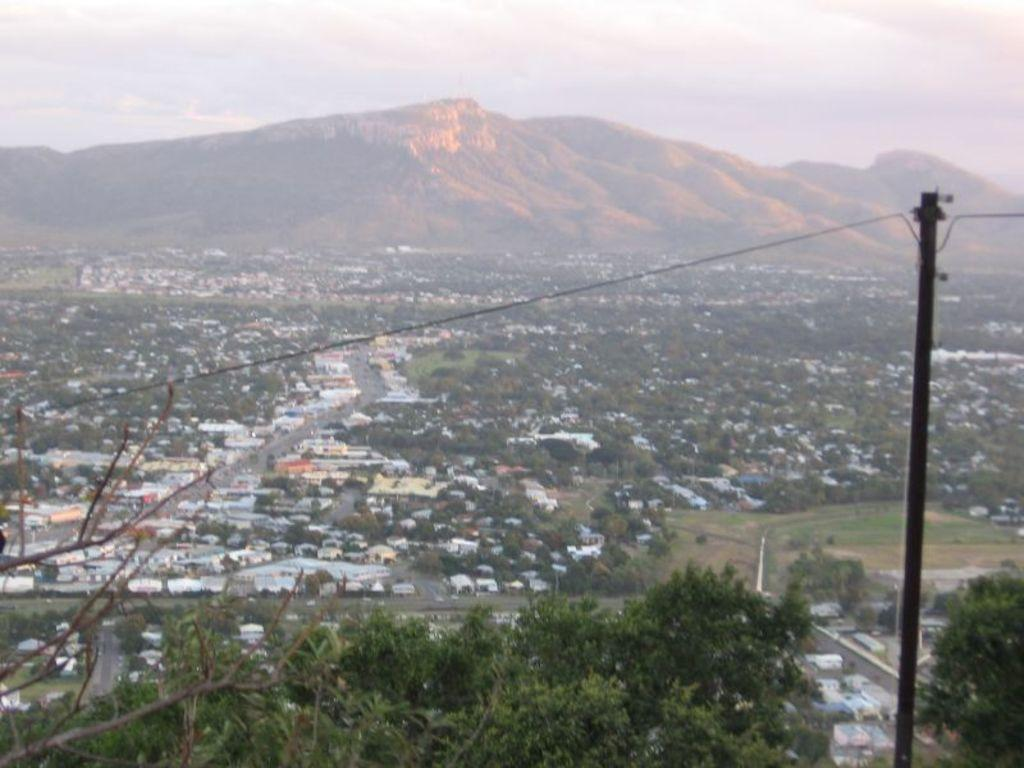What is located on the right side of the image? There is a pole with a cable on the right side of the image. What can be seen in the background of the image? There are buildings, trees, and mountains in the background of the image. What is visible on the ground in the image? The ground is visible in the image. What is present in the sky in the image? There are clouds in the sky. What type of game is being played by the uncle and the beast in the image? There is no uncle or beast present in the image, and therefore no such game can be observed. 